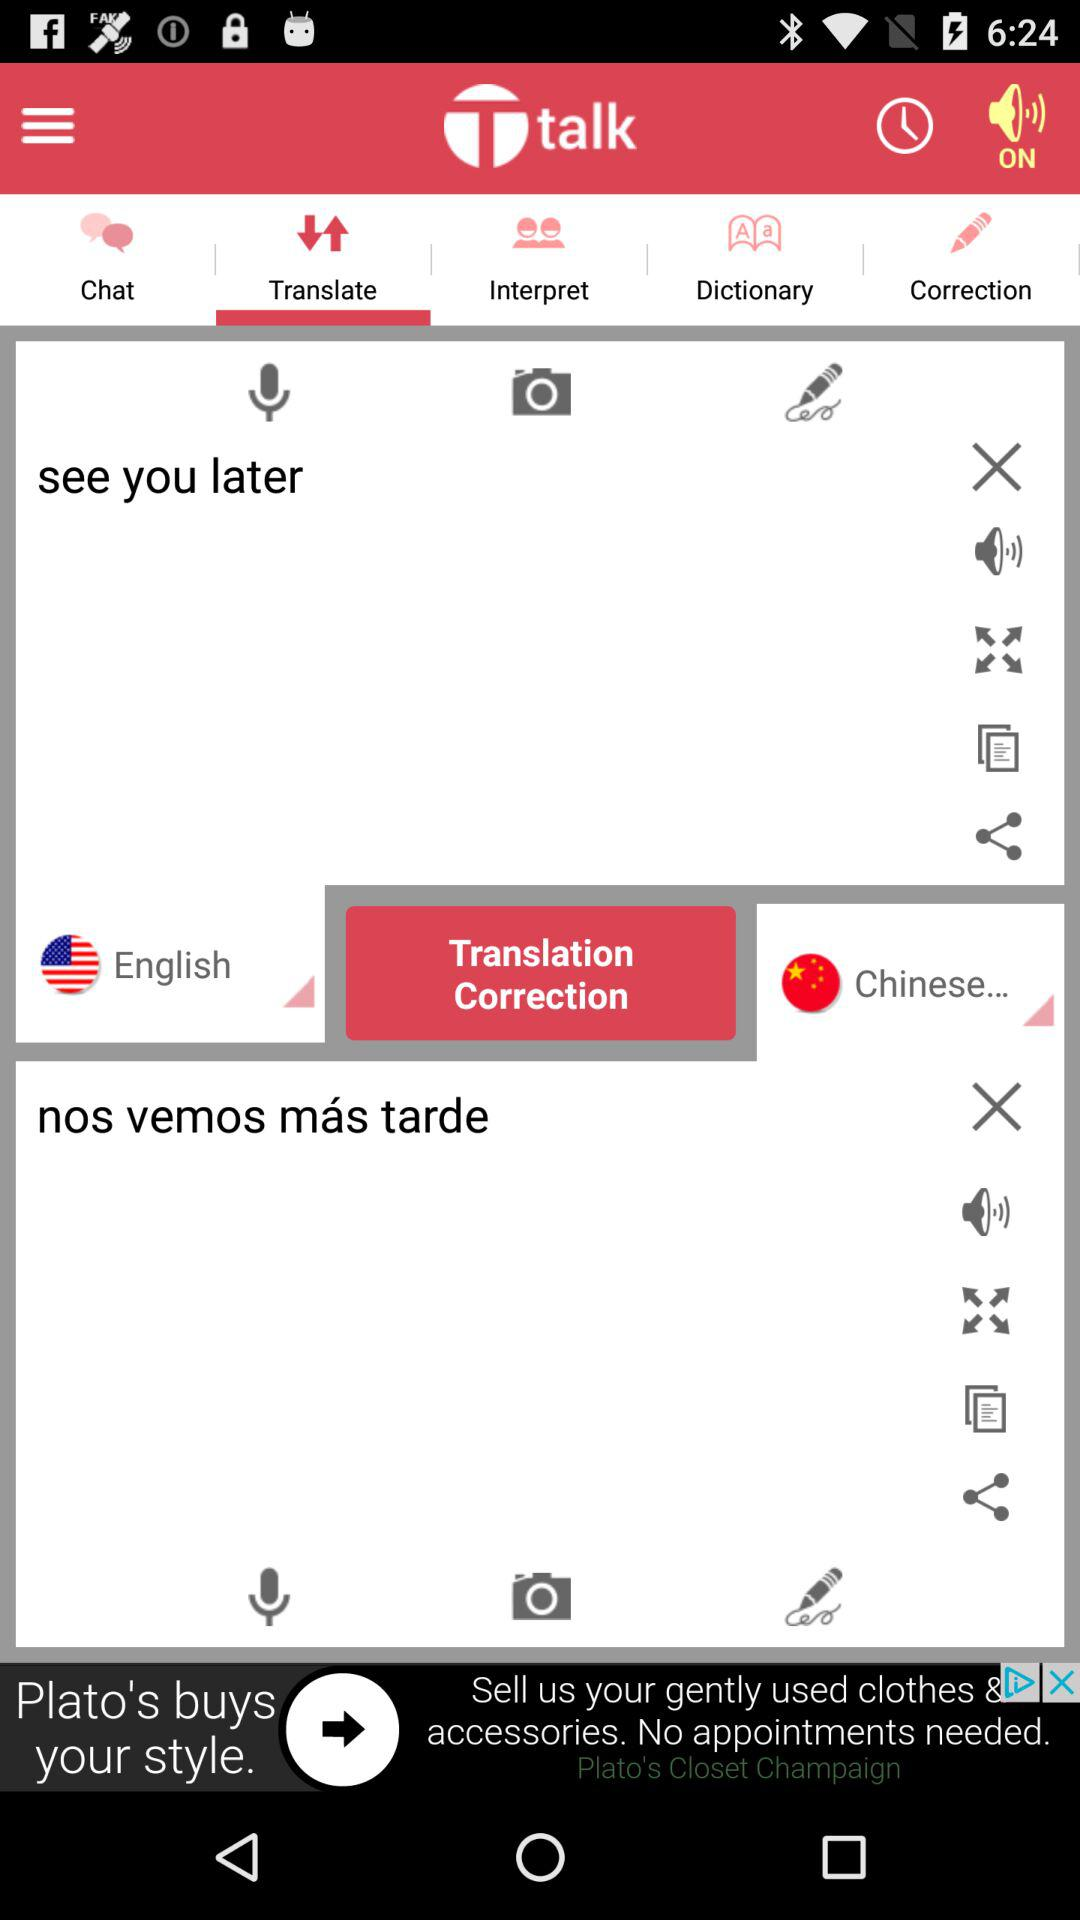Which tab is selected? The selected tab is "Translate". 